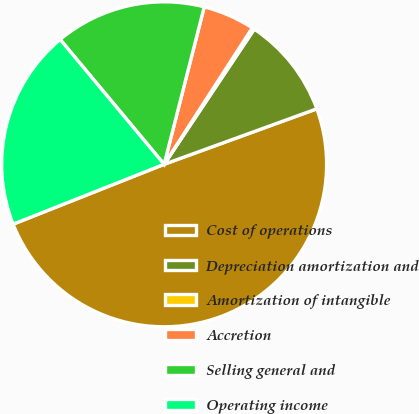Convert chart. <chart><loc_0><loc_0><loc_500><loc_500><pie_chart><fcel>Cost of operations<fcel>Depreciation amortization and<fcel>Amortization of intangible<fcel>Accretion<fcel>Selling general and<fcel>Operating income<nl><fcel>49.53%<fcel>10.09%<fcel>0.23%<fcel>5.16%<fcel>15.02%<fcel>19.95%<nl></chart> 